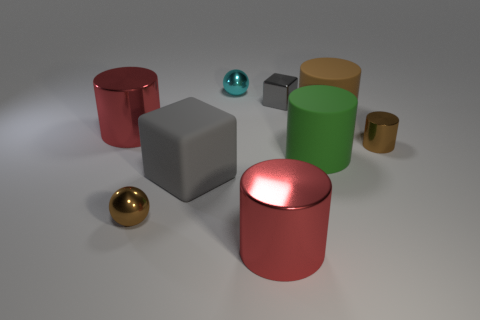Subtract all tiny metallic cylinders. How many cylinders are left? 4 Add 1 big yellow rubber cylinders. How many objects exist? 10 Subtract all cylinders. How many objects are left? 4 Subtract 2 cylinders. How many cylinders are left? 3 Subtract all purple cubes. How many brown balls are left? 1 Subtract all brown cylinders. How many cylinders are left? 3 Subtract 0 brown blocks. How many objects are left? 9 Subtract all cyan spheres. Subtract all green blocks. How many spheres are left? 1 Subtract all large gray things. Subtract all small brown cylinders. How many objects are left? 7 Add 8 red cylinders. How many red cylinders are left? 10 